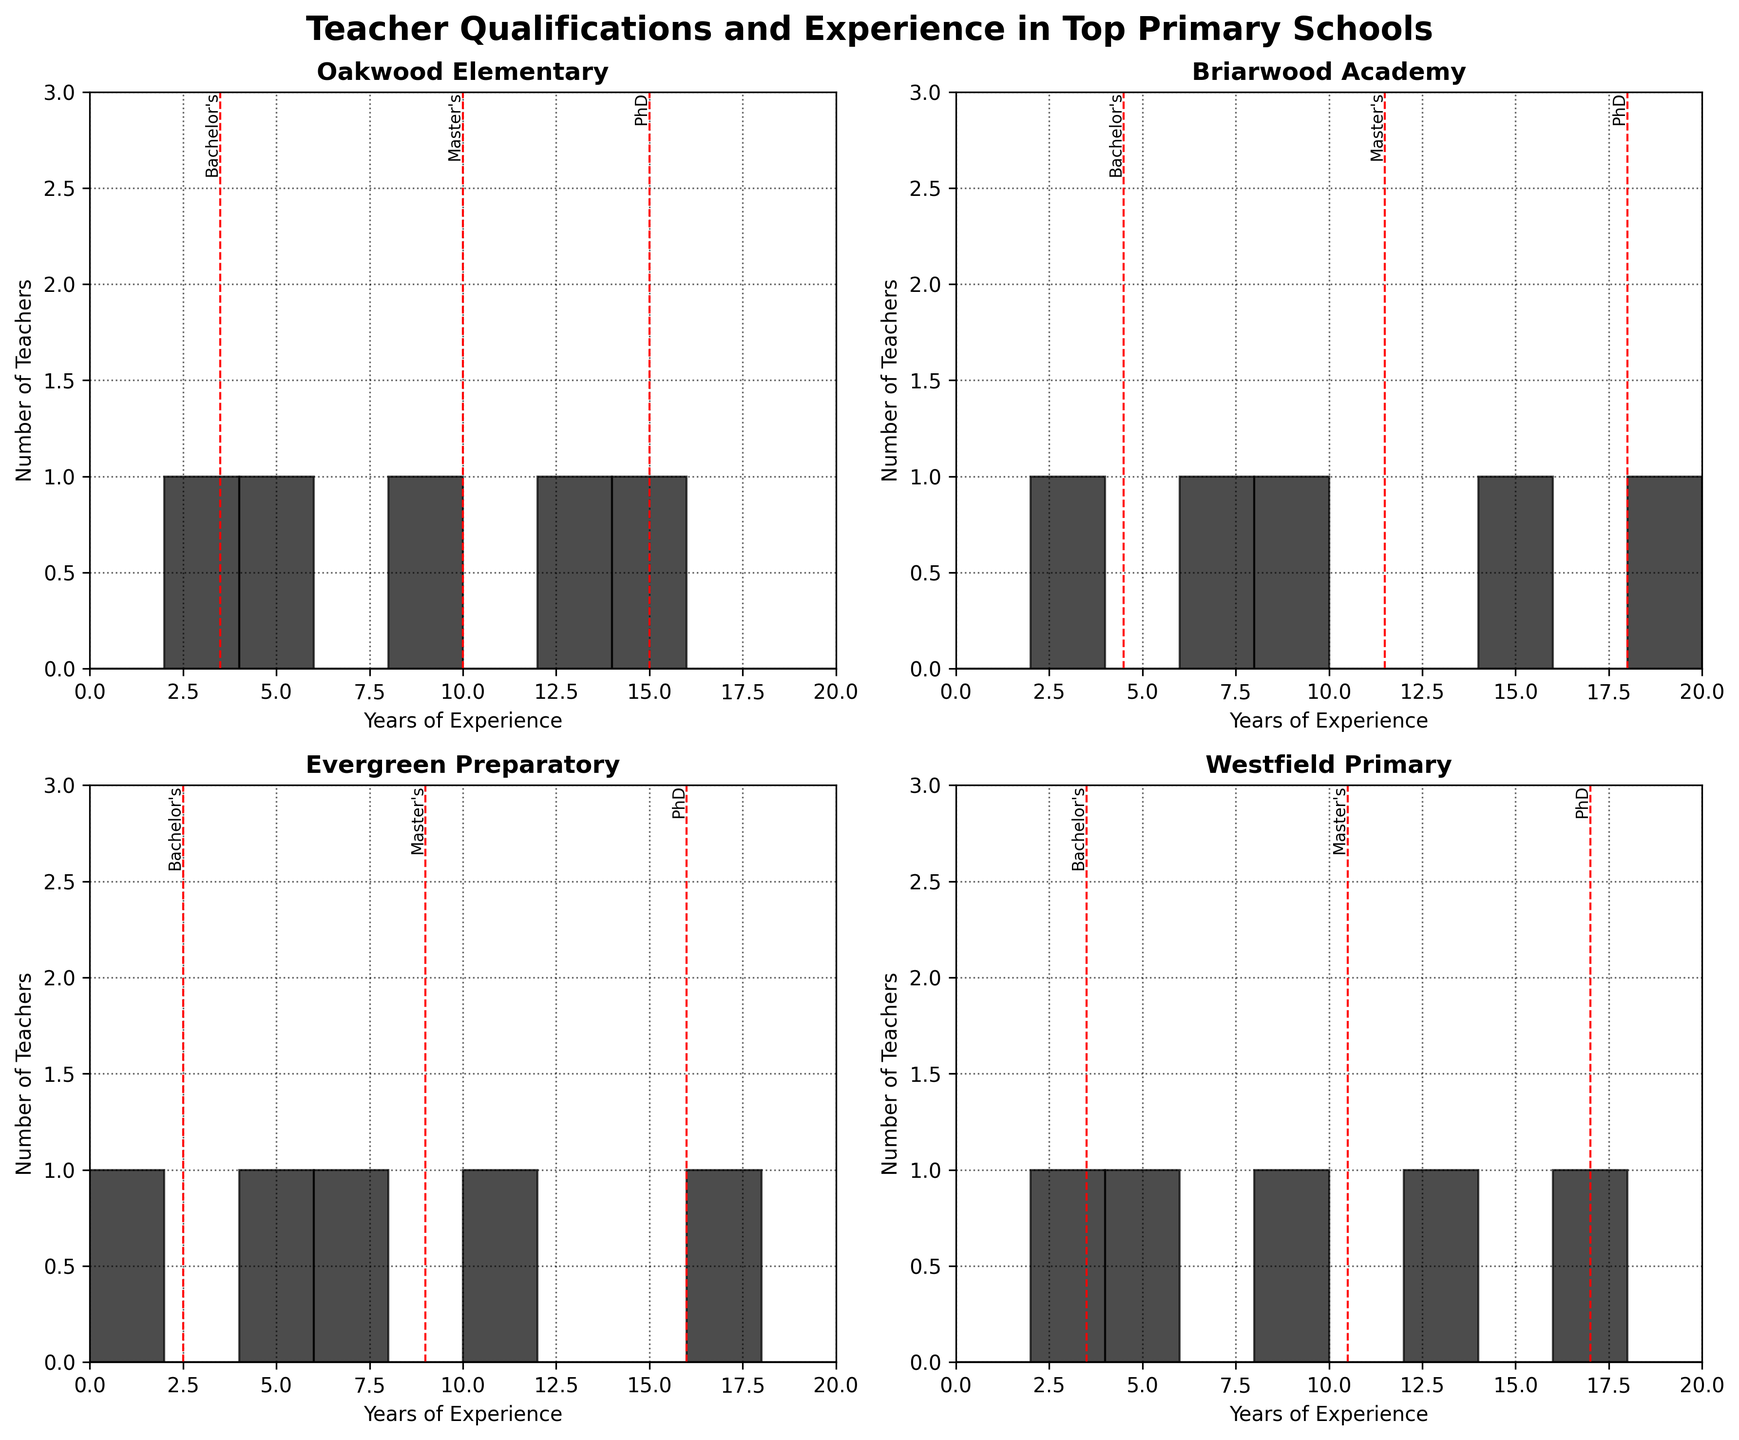How many schools are represented in the figure? The figure contains four subplots, each titled with a different school name, indicating there are four schools represented.
Answer: 4 Which school has the highest number of teachers with a PhD? The y-axis of each subplot shows the count of teachers. Comparing the highest bar in each subplot for the "PhD" qualification, "Briarwood Academy" has the highest count with a visible bar reaching the "3" mark.
Answer: Briarwood Academy Which school has the teachers with the least average years of experience? To determine this, compare the position of the red dashed lines representing the mean years of experience for each subplot. The school with the lowest position of this line across all qualifications has the least average years of experience. "Evergreen Preparatory" appears to have the lowest overall average mean.
Answer: Evergreen Preparatory What is the common qualification with the most teachers in Oakwood Elementary? In the Oakwood Elementary subplot, the heights of the bars representing different qualifications can be compared. "Bachelor’s" appears to be the qualification with the most teachers when measuring the height of the corresponding bars.
Answer: Bachelor's Between Bachelor’s and Master’s degrees, which has a larger range of years of experience in Westfield Primary? To find the range, observe the span of years covered by the bars for each qualification; between Bachelor’s and Master’s, Bachelor’s spans from 2 to 5 years, while Master’s spans from 8 to 13 years. The range for Bachelor’s is 3 (5-2) while for Master’s it is 5 years (13-8), making Master’s the qualification with the larger range of years of experience in Westfield Primary.
Answer: Master's How many teachers in Briarwood Academy have over 10 years of experience? Count the bars for Briarwood Academy that represent teachers with more than 10 years of experience. There are two bars to the right of the 10-year mark, each with 1 teacher, making the total 2.
Answer: 2 What distinct qualifications are represented in each subplot? By observing the qualifications denoted by red lines and text in each subplot:
- Oakwood Elementary: Bachelor’s, Master’s, PhD
- Briarwood Academy: Bachelor’s, Master’s, PhD
- Evergreen Preparatory: Bachelor’s, Master’s, PhD
- Westfield Primary: Bachelor’s, Master’s, PhD
Answer: Bachelor’s, Master’s, PhD Which school has the highest average years of experience among teachers holding a Master’s degree? The average years of experience for teachers holding a Master’s can be seen by the red dashed lines. Observe which of these is positioned furthest to the right:
- Oakwood Elementary: ~10
- Briarwood Academy: ~11.5
- Evergreen Preparatory: ~9
- Westfield Primary: ~10.5. 
Briarwood Academy has the highest average at about 11.5 years.
Answer: Briarwood Academy What is the maximum number of teachers with less than 5 years of experience across any of the schools? By examining bars on each subplot indicating less than 5 years, the tallest bar under 5 years appears in Evergreen Preparatory with a bar at "Bachelor’s" level reaching to 2 teachers.
Answer: 2 